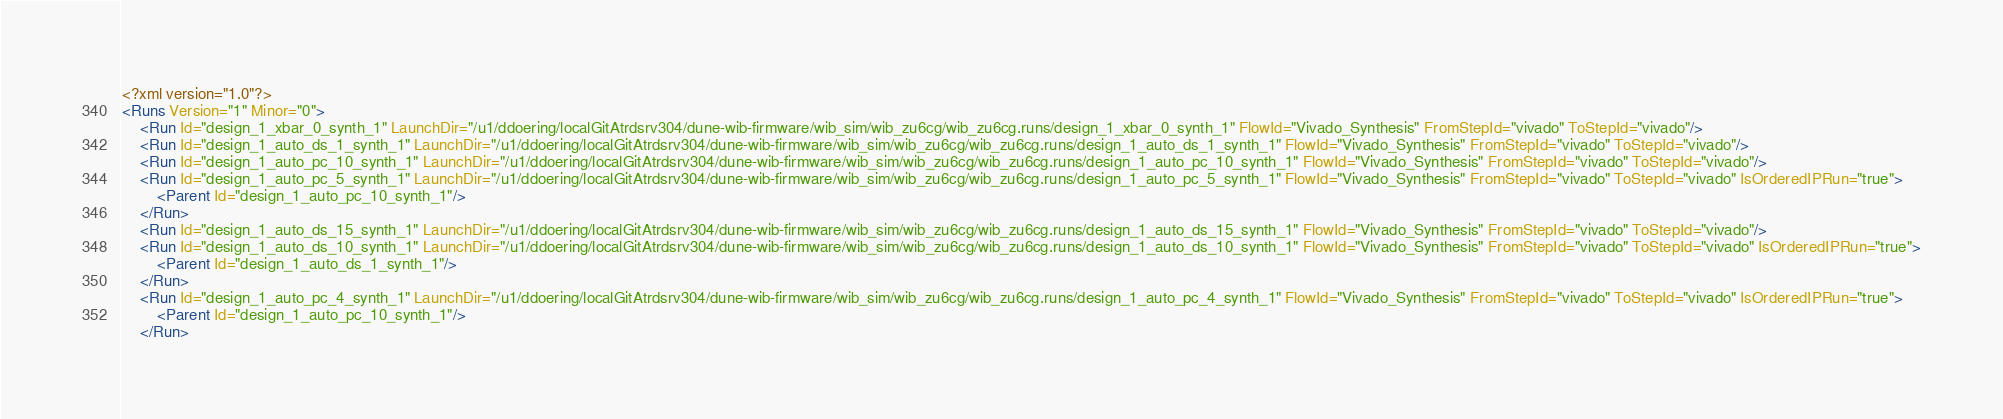Convert code to text. <code><loc_0><loc_0><loc_500><loc_500><_XML_><?xml version="1.0"?>
<Runs Version="1" Minor="0">
	<Run Id="design_1_xbar_0_synth_1" LaunchDir="/u1/ddoering/localGitAtrdsrv304/dune-wib-firmware/wib_sim/wib_zu6cg/wib_zu6cg.runs/design_1_xbar_0_synth_1" FlowId="Vivado_Synthesis" FromStepId="vivado" ToStepId="vivado"/>
	<Run Id="design_1_auto_ds_1_synth_1" LaunchDir="/u1/ddoering/localGitAtrdsrv304/dune-wib-firmware/wib_sim/wib_zu6cg/wib_zu6cg.runs/design_1_auto_ds_1_synth_1" FlowId="Vivado_Synthesis" FromStepId="vivado" ToStepId="vivado"/>
	<Run Id="design_1_auto_pc_10_synth_1" LaunchDir="/u1/ddoering/localGitAtrdsrv304/dune-wib-firmware/wib_sim/wib_zu6cg/wib_zu6cg.runs/design_1_auto_pc_10_synth_1" FlowId="Vivado_Synthesis" FromStepId="vivado" ToStepId="vivado"/>
	<Run Id="design_1_auto_pc_5_synth_1" LaunchDir="/u1/ddoering/localGitAtrdsrv304/dune-wib-firmware/wib_sim/wib_zu6cg/wib_zu6cg.runs/design_1_auto_pc_5_synth_1" FlowId="Vivado_Synthesis" FromStepId="vivado" ToStepId="vivado" IsOrderedIPRun="true">
		<Parent Id="design_1_auto_pc_10_synth_1"/>
	</Run>
	<Run Id="design_1_auto_ds_15_synth_1" LaunchDir="/u1/ddoering/localGitAtrdsrv304/dune-wib-firmware/wib_sim/wib_zu6cg/wib_zu6cg.runs/design_1_auto_ds_15_synth_1" FlowId="Vivado_Synthesis" FromStepId="vivado" ToStepId="vivado"/>
	<Run Id="design_1_auto_ds_10_synth_1" LaunchDir="/u1/ddoering/localGitAtrdsrv304/dune-wib-firmware/wib_sim/wib_zu6cg/wib_zu6cg.runs/design_1_auto_ds_10_synth_1" FlowId="Vivado_Synthesis" FromStepId="vivado" ToStepId="vivado" IsOrderedIPRun="true">
		<Parent Id="design_1_auto_ds_1_synth_1"/>
	</Run>
	<Run Id="design_1_auto_pc_4_synth_1" LaunchDir="/u1/ddoering/localGitAtrdsrv304/dune-wib-firmware/wib_sim/wib_zu6cg/wib_zu6cg.runs/design_1_auto_pc_4_synth_1" FlowId="Vivado_Synthesis" FromStepId="vivado" ToStepId="vivado" IsOrderedIPRun="true">
		<Parent Id="design_1_auto_pc_10_synth_1"/>
	</Run></code> 